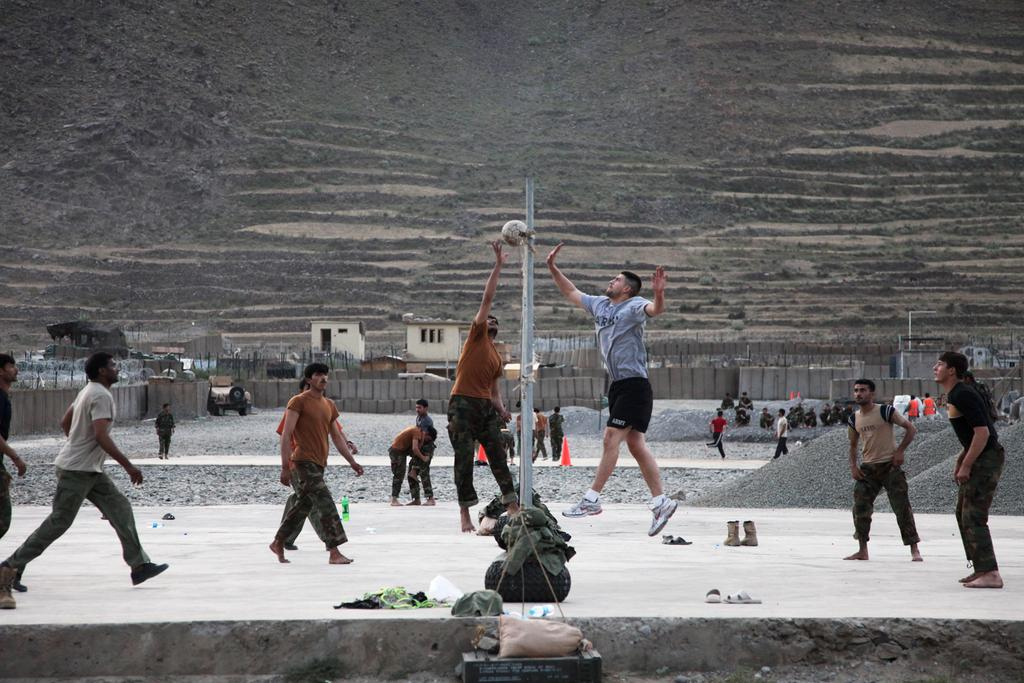What are the people in the image doing? The people in the image are standing, walking, and jumping. What structures can be seen in the image? There are poles and fencing in the image. What type of buildings are visible in the image? There are houses in the image. What objects can be found on the ground in the image? There are bottles and a shoe in the image. What natural feature is visible at the top of the image? There is a hill visible at the top of the image. What is the rate of the pump in the image? There is no pump present in the image, so it is not possible to determine its rate. 